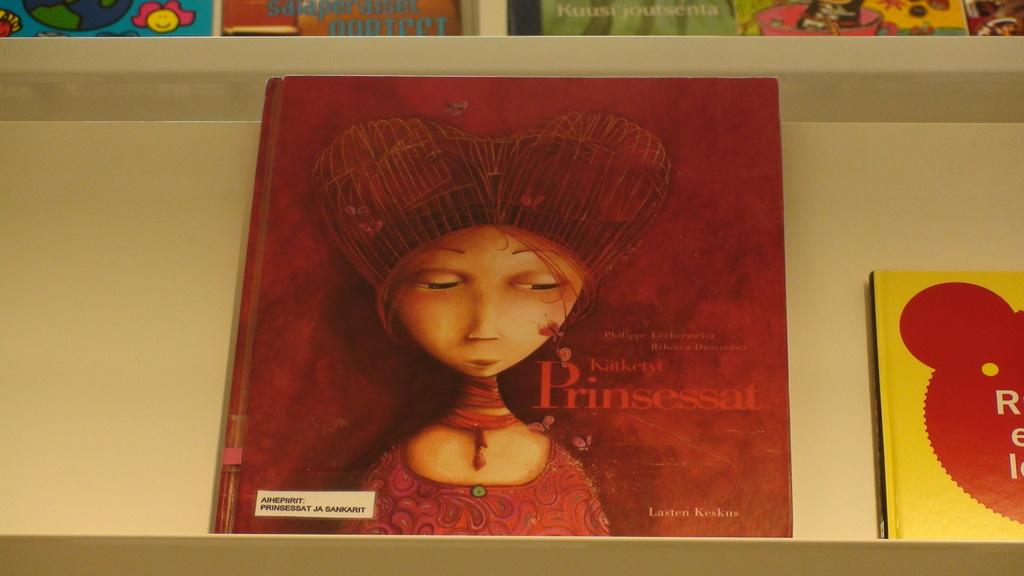What is the main object in the image? There is a rack in the image. What is stored on the rack? The rack contains many books. What type of suit is the partner wearing in the image? There is no partner or suit present in the image; it only features a rack with books. 